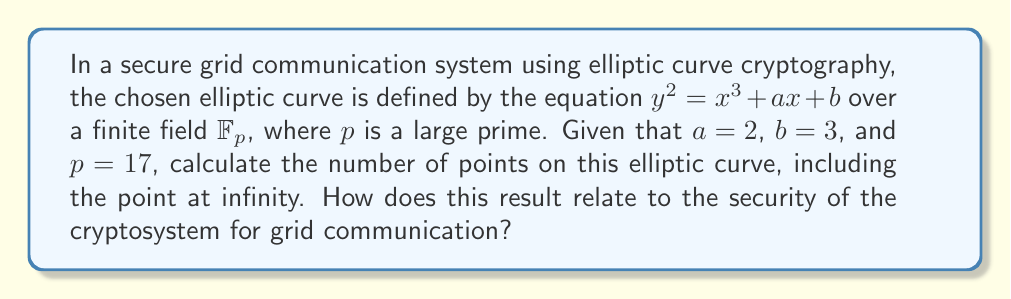Can you solve this math problem? To solve this problem, we need to follow these steps:

1) The elliptic curve equation is $y^2 = x^3 + 2x + 3$ over $\mathbb{F}_{17}$.

2) We need to count the number of points $(x,y)$ that satisfy this equation in $\mathbb{F}_{17}$, plus the point at infinity.

3) For each $x \in \mathbb{F}_{17}$, we calculate $x^3 + 2x + 3 \mod 17$ and check if it's a quadratic residue modulo 17.

4) If it's a quadratic residue, it contributes 2 points to the curve (as both $y$ and $-y$ will be solutions). If it's 0, it contributes 1 point.

Let's calculate:

For $x = 0$: $0^3 + 2(0) + 3 \equiv 3 \pmod{17}$
For $x = 1$: $1^3 + 2(1) + 3 \equiv 6 \pmod{17}$
For $x = 2$: $2^3 + 2(2) + 3 \equiv 15 \pmod{17}$
For $x = 3$: $3^3 + 2(3) + 3 \equiv 9 \pmod{17}$
For $x = 4$: $4^3 + 2(4) + 3 \equiv 13 \pmod{17}$
For $x = 5$: $5^3 + 2(5) + 3 \equiv 1 \pmod{17}$
For $x = 6$: $6^3 + 2(6) + 3 \equiv 9 \pmod{17}$
For $x = 7$: $7^3 + 2(7) + 3 \equiv 2 \pmod{17}$
For $x = 8$: $8^3 + 2(8) + 3 \equiv 0 \pmod{17}$
For $x = 9$: $9^3 + 2(9) + 3 \equiv 9 \pmod{17}$
For $x = 10$: $10^3 + 2(10) + 3 \equiv 6 \pmod{17}$
For $x = 11$: $11^3 + 2(11) + 3 \equiv 0 \pmod{17}$
For $x = 12$: $12^3 + 2(12) + 3 \equiv 0 \pmod{17}$
For $x = 13$: $13^3 + 2(13) + 3 \equiv 4 \pmod{17}$
For $x = 14$: $14^3 + 2(14) + 3 \equiv 2 \pmod{17}$
For $x = 15$: $15^3 + 2(15) + 3 \equiv 13 \pmod{17}$
For $x = 16$: $16^3 + 2(16) + 3 \equiv 15 \pmod{17}$

The quadratic residues modulo 17 are: 1, 2, 4, 8, 9, 13, 15, 16

Therefore, we have:
- 8 values of $x$ that give quadratic residues (contributing 16 points)
- 3 values of $x$ that give 0 (contributing 3 points)
- 1 point at infinity

Total number of points: $16 + 3 + 1 = 20$

Regarding security, the number of points on the curve is crucial. For a secure elliptic curve cryptosystem, this number (often denoted as $N$) should have a large prime factor. In this case, $N = 20 = 2^2 * 5$, which is not suitable for cryptographic purposes due to its small factors. In practice, much larger primes are used, typically of 256 bits or more, to ensure the difficulty of the discrete logarithm problem on which the security of elliptic curve cryptography relies.
Answer: The elliptic curve $y^2 = x^3 + 2x + 3$ over $\mathbb{F}_{17}$ has 20 points, including the point at infinity. This small number with only small prime factors (2 and 5) makes it unsuitable for secure grid communication, as it wouldn't provide sufficient cryptographic strength against attacks. 